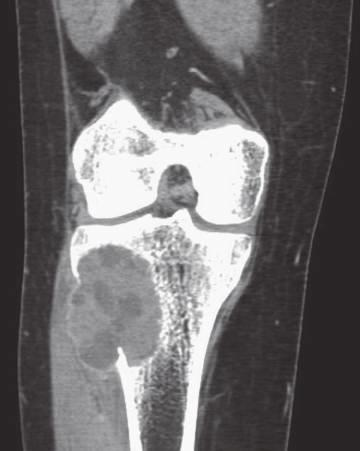does the transmural light area in the posterolateral left ventricle scan show eccentric aneurysmal bone cyst of tibia?
Answer the question using a single word or phrase. No 